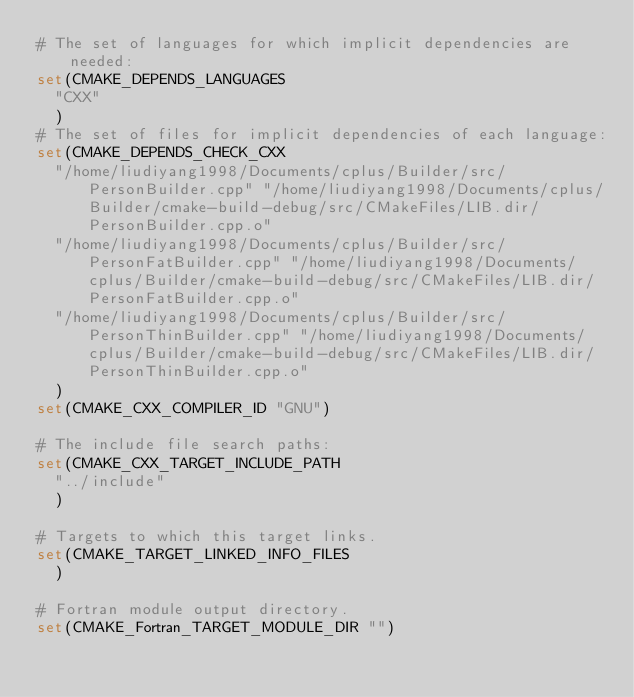<code> <loc_0><loc_0><loc_500><loc_500><_CMake_># The set of languages for which implicit dependencies are needed:
set(CMAKE_DEPENDS_LANGUAGES
  "CXX"
  )
# The set of files for implicit dependencies of each language:
set(CMAKE_DEPENDS_CHECK_CXX
  "/home/liudiyang1998/Documents/cplus/Builder/src/PersonBuilder.cpp" "/home/liudiyang1998/Documents/cplus/Builder/cmake-build-debug/src/CMakeFiles/LIB.dir/PersonBuilder.cpp.o"
  "/home/liudiyang1998/Documents/cplus/Builder/src/PersonFatBuilder.cpp" "/home/liudiyang1998/Documents/cplus/Builder/cmake-build-debug/src/CMakeFiles/LIB.dir/PersonFatBuilder.cpp.o"
  "/home/liudiyang1998/Documents/cplus/Builder/src/PersonThinBuilder.cpp" "/home/liudiyang1998/Documents/cplus/Builder/cmake-build-debug/src/CMakeFiles/LIB.dir/PersonThinBuilder.cpp.o"
  )
set(CMAKE_CXX_COMPILER_ID "GNU")

# The include file search paths:
set(CMAKE_CXX_TARGET_INCLUDE_PATH
  "../include"
  )

# Targets to which this target links.
set(CMAKE_TARGET_LINKED_INFO_FILES
  )

# Fortran module output directory.
set(CMAKE_Fortran_TARGET_MODULE_DIR "")
</code> 